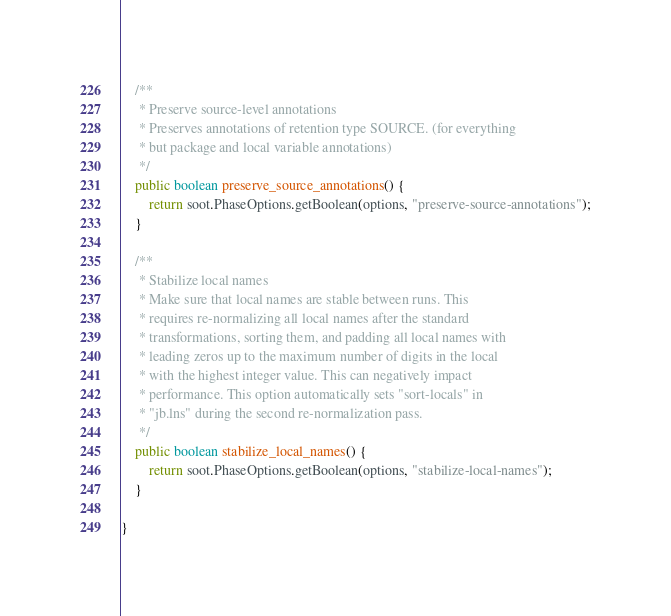Convert code to text. <code><loc_0><loc_0><loc_500><loc_500><_Java_>
    /**
     * Preserve source-level annotations
     * Preserves annotations of retention type SOURCE. (for everything 
     * but package and local variable annotations)
     */
    public boolean preserve_source_annotations() {
        return soot.PhaseOptions.getBoolean(options, "preserve-source-annotations");
    }

    /**
     * Stabilize local names
     * Make sure that local names are stable between runs. This 
     * requires re-normalizing all local names after the standard 
     * transformations, sorting them, and padding all local names with 
     * leading zeros up to the maximum number of digits in the local 
     * with the highest integer value. This can negatively impact 
     * performance. This option automatically sets "sort-locals" in 
     * "jb.lns" during the second re-normalization pass.
     */
    public boolean stabilize_local_names() {
        return soot.PhaseOptions.getBoolean(options, "stabilize-local-names");
    }

}
</code> 